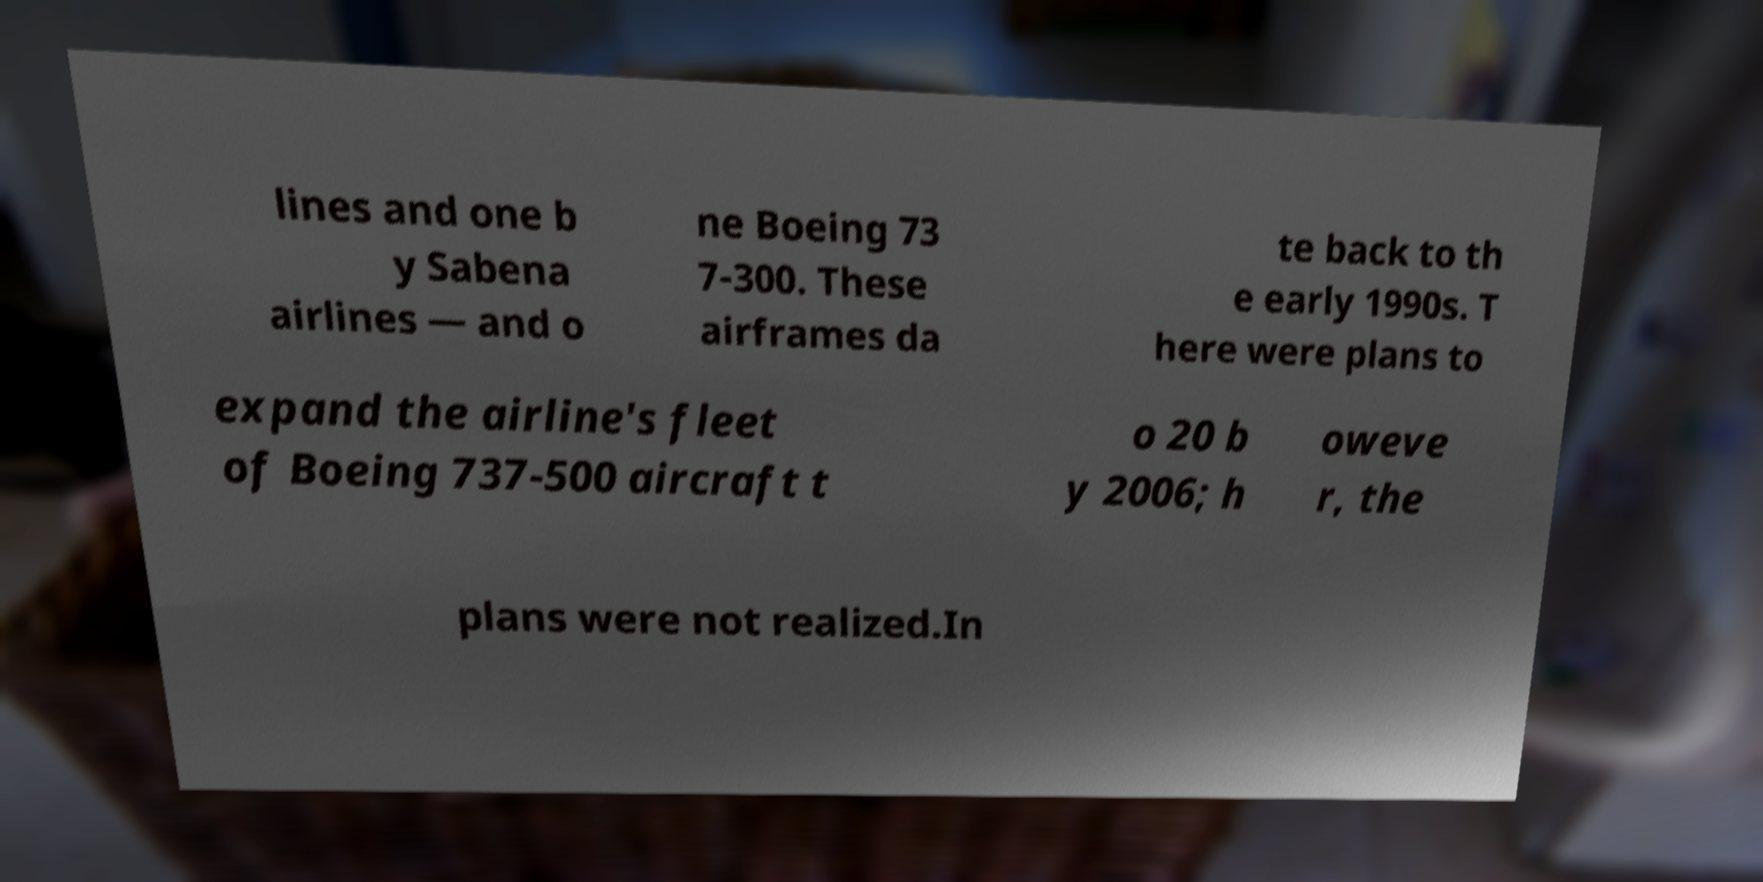What messages or text are displayed in this image? I need them in a readable, typed format. lines and one b y Sabena airlines — and o ne Boeing 73 7-300. These airframes da te back to th e early 1990s. T here were plans to expand the airline's fleet of Boeing 737-500 aircraft t o 20 b y 2006; h oweve r, the plans were not realized.In 